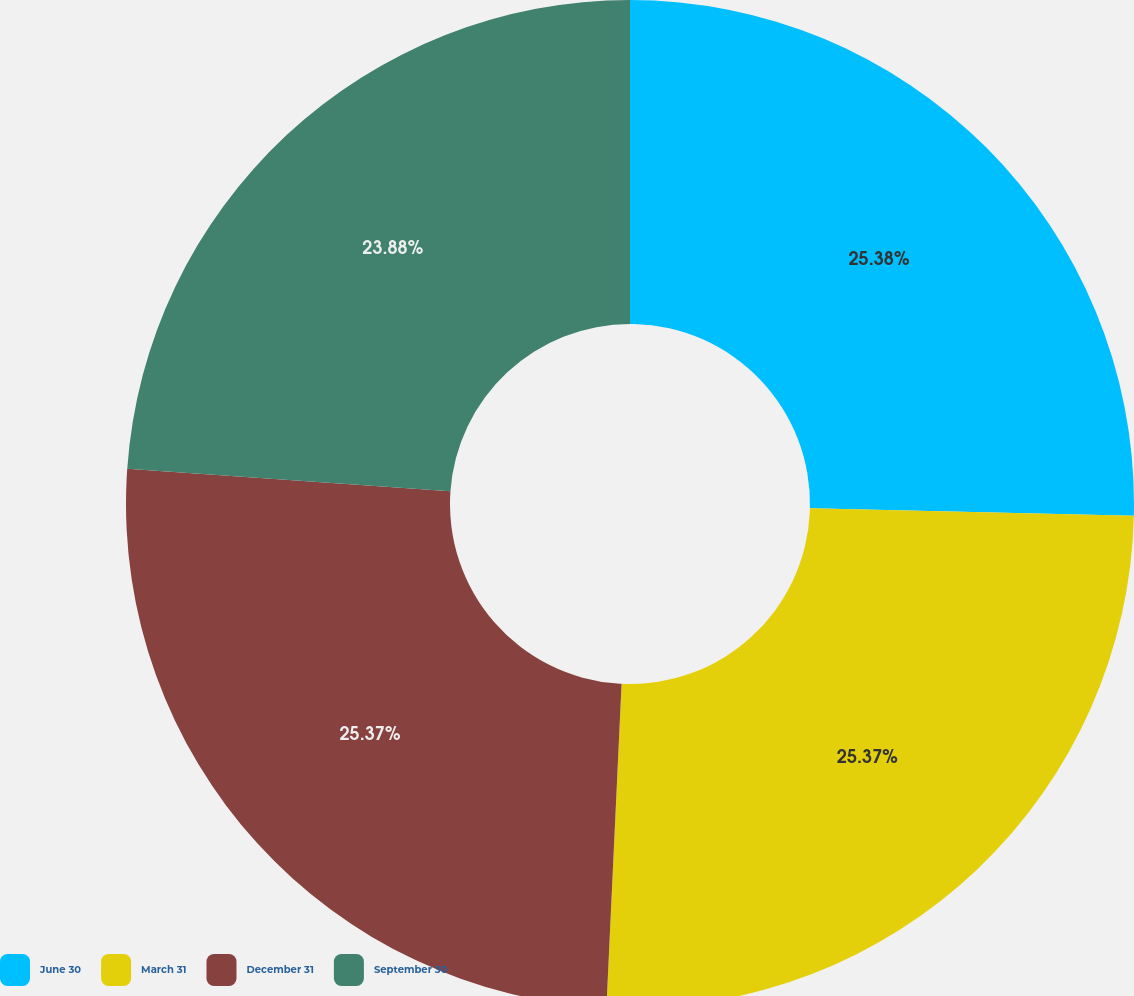<chart> <loc_0><loc_0><loc_500><loc_500><pie_chart><fcel>June 30<fcel>March 31<fcel>December 31<fcel>September 30<nl><fcel>25.37%<fcel>25.37%<fcel>25.37%<fcel>23.88%<nl></chart> 